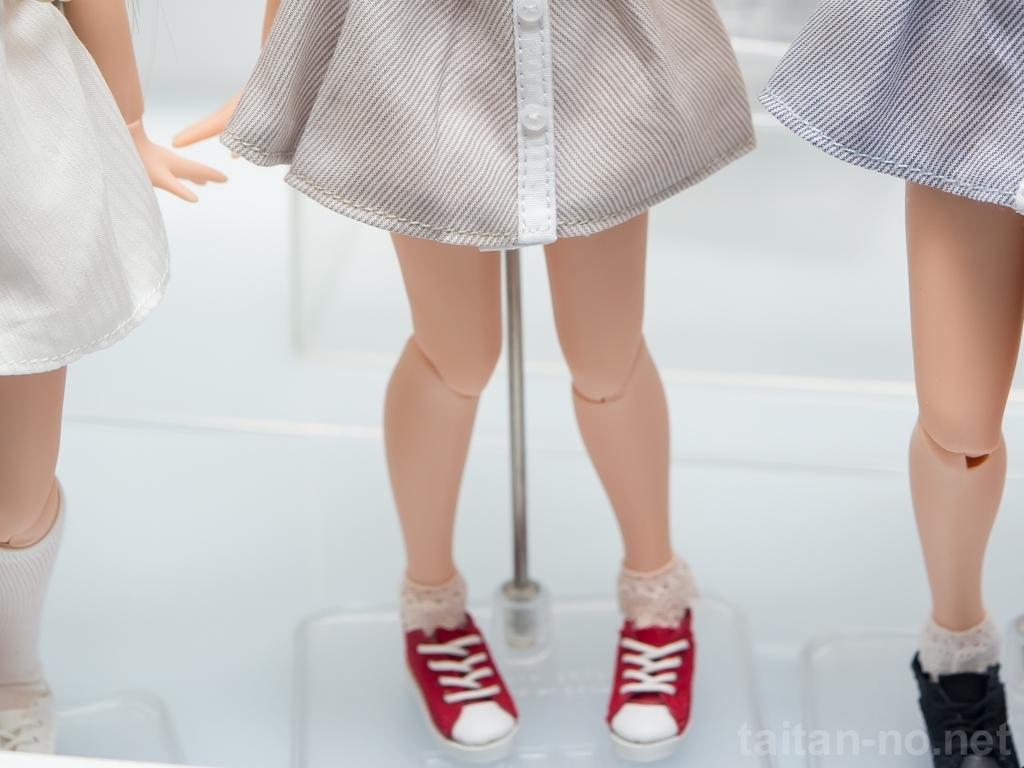Can you speculate on the context or purpose of this image? The image seems staged, likely for commercial or artistic purposes. The plain background and bright lighting highlight the figures and their attire, which are positioned on clear acrylic stands, suggesting this could be a display within a retail setting, perhaps a boutique or a window display designed to showcase the latest fashion trends. Alternatively, it might be part of a fashion photography session aiming to capture a unique blend of style elements. 